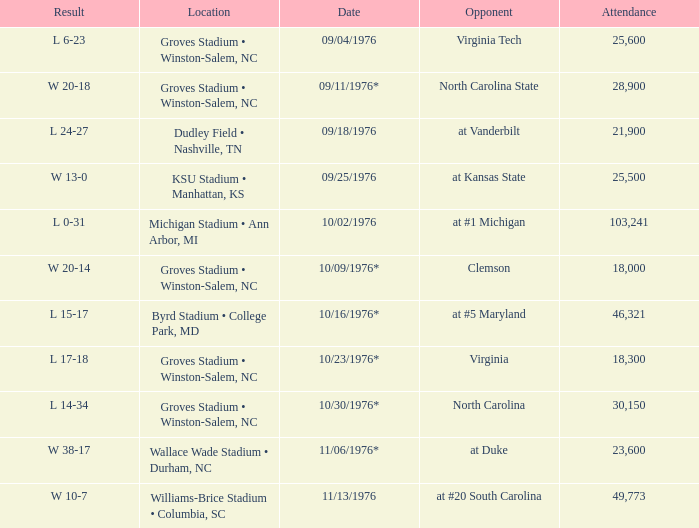What was the date of the game against North Carolina? 10/30/1976*. 